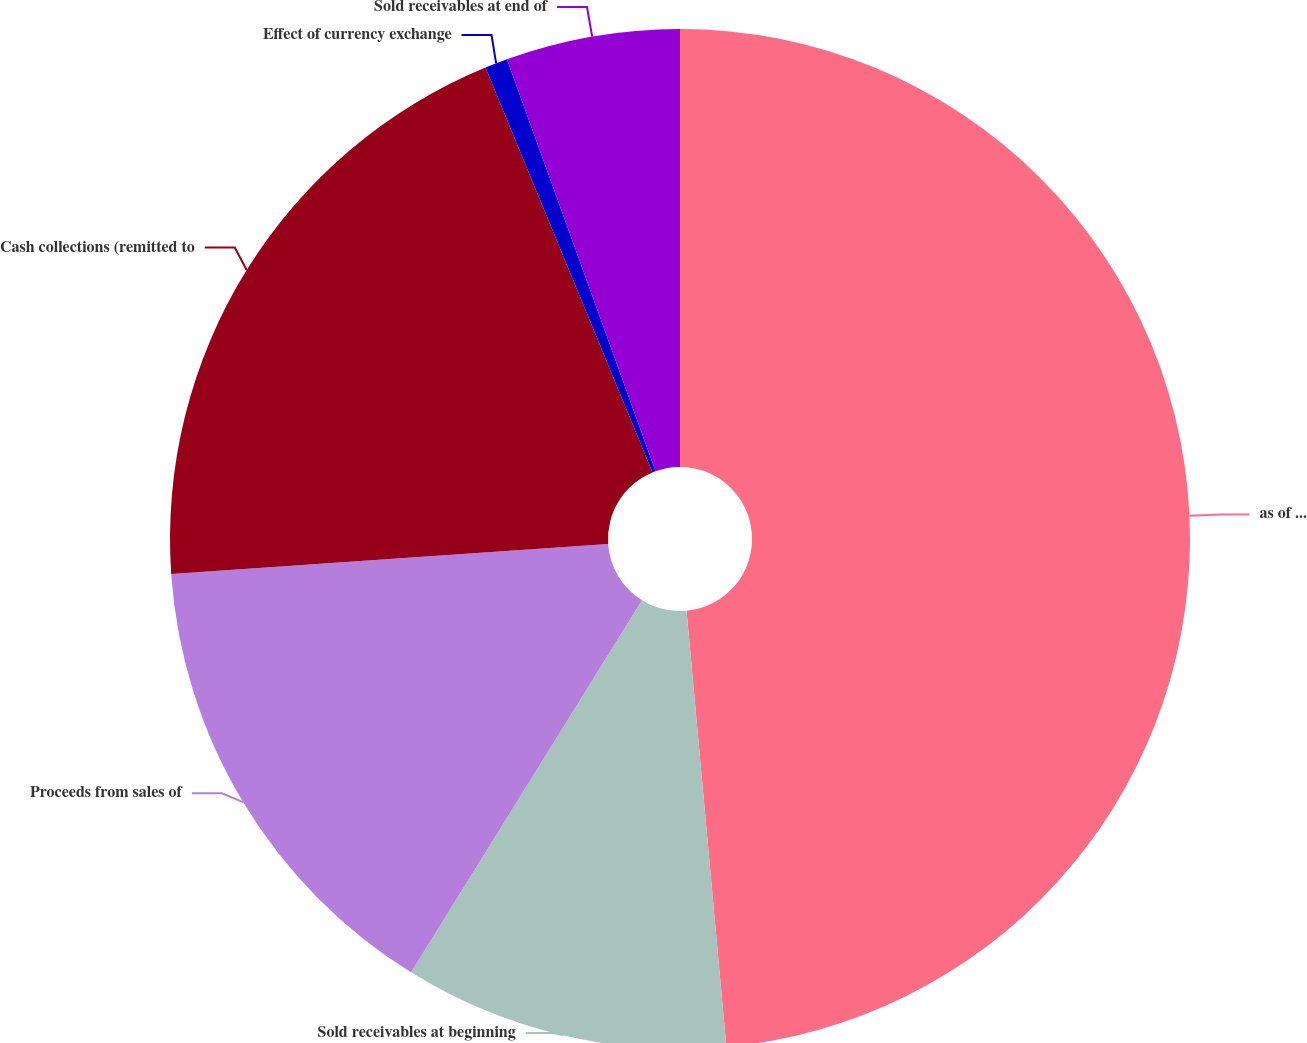Convert chart to OTSL. <chart><loc_0><loc_0><loc_500><loc_500><pie_chart><fcel>as of and for the years ended<fcel>Sold receivables at beginning<fcel>Proceeds from sales of<fcel>Cash collections (remitted to<fcel>Effect of currency exchange<fcel>Sold receivables at end of<nl><fcel>48.55%<fcel>10.29%<fcel>15.07%<fcel>19.86%<fcel>0.72%<fcel>5.51%<nl></chart> 